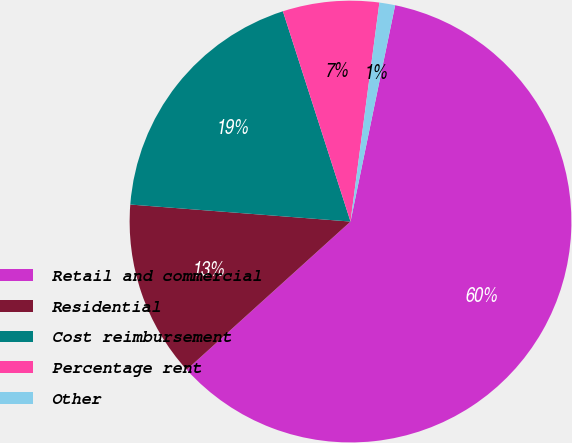Convert chart. <chart><loc_0><loc_0><loc_500><loc_500><pie_chart><fcel>Retail and commercial<fcel>Residential<fcel>Cost reimbursement<fcel>Percentage rent<fcel>Other<nl><fcel>60.06%<fcel>12.93%<fcel>18.82%<fcel>7.04%<fcel>1.15%<nl></chart> 